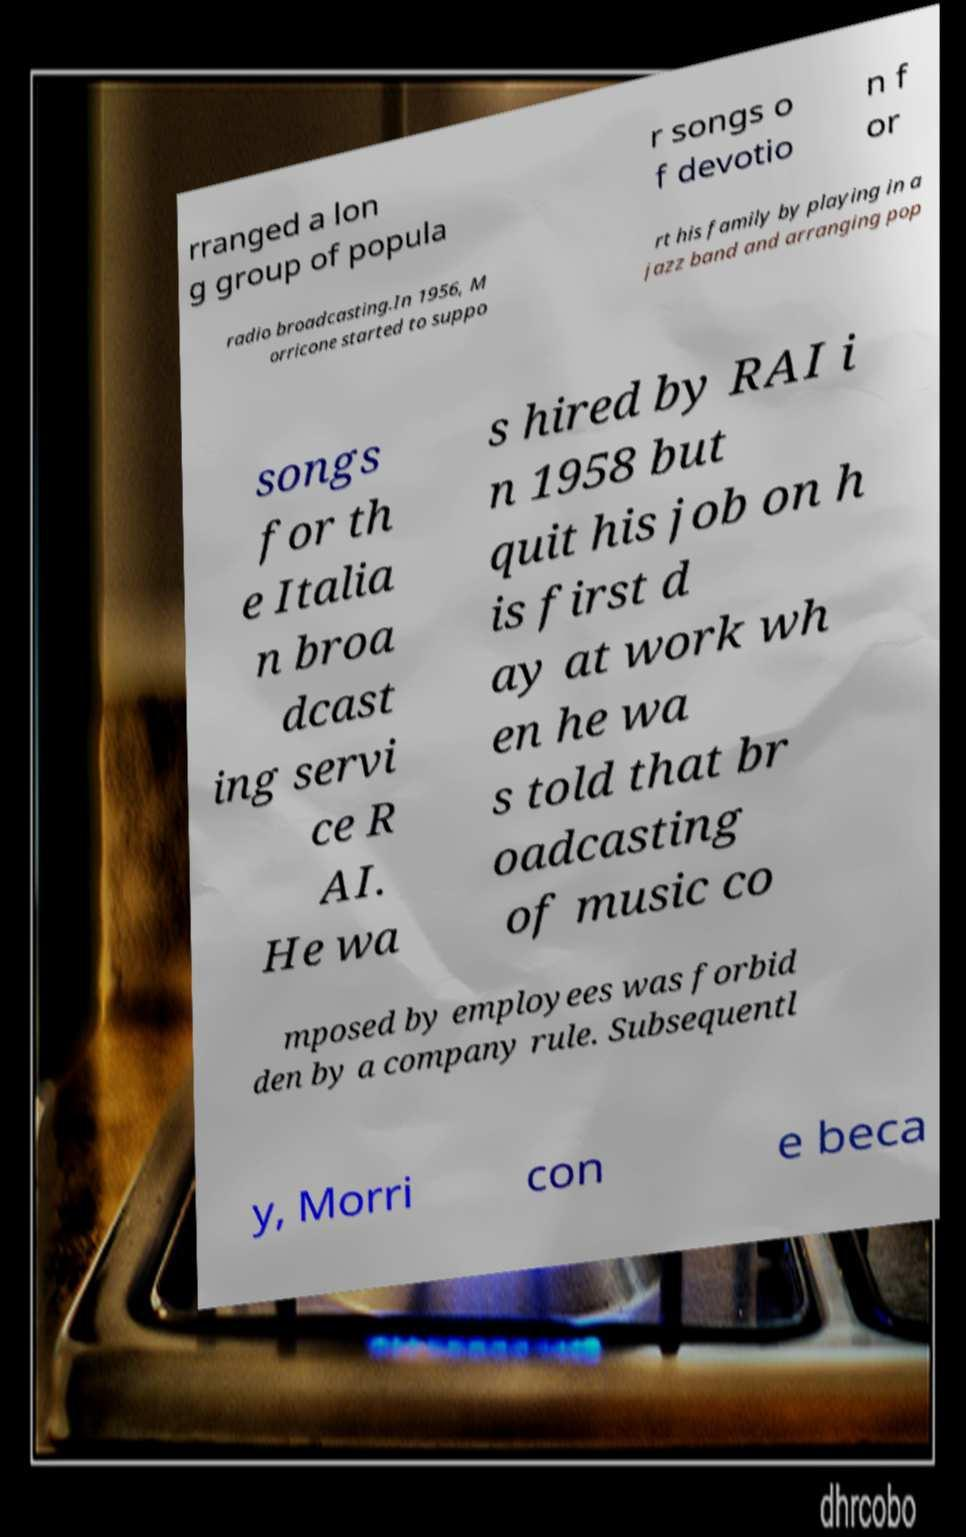What messages or text are displayed in this image? I need them in a readable, typed format. rranged a lon g group of popula r songs o f devotio n f or radio broadcasting.In 1956, M orricone started to suppo rt his family by playing in a jazz band and arranging pop songs for th e Italia n broa dcast ing servi ce R AI. He wa s hired by RAI i n 1958 but quit his job on h is first d ay at work wh en he wa s told that br oadcasting of music co mposed by employees was forbid den by a company rule. Subsequentl y, Morri con e beca 